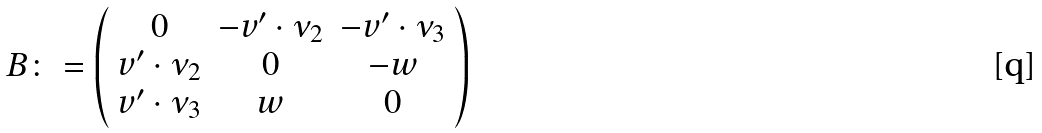Convert formula to latex. <formula><loc_0><loc_0><loc_500><loc_500>B \colon = \left ( \begin{array} { c } 0 \\ v ^ { \prime } \cdot \nu _ { 2 } \\ v ^ { \prime } \cdot \nu _ { 3 } \end{array} \begin{array} { c } - v ^ { \prime } \cdot \nu _ { 2 } \\ 0 \\ w \end{array} \begin{array} { c } - v ^ { \prime } \cdot \nu _ { 3 } \\ - w \\ 0 \end{array} \right )</formula> 